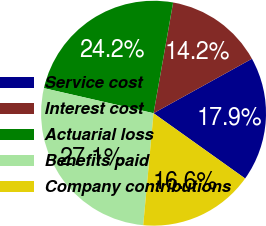<chart> <loc_0><loc_0><loc_500><loc_500><pie_chart><fcel>Service cost<fcel>Interest cost<fcel>Actuarial loss<fcel>Benefits paid<fcel>Company contributions<nl><fcel>17.9%<fcel>14.17%<fcel>24.21%<fcel>27.11%<fcel>16.61%<nl></chart> 